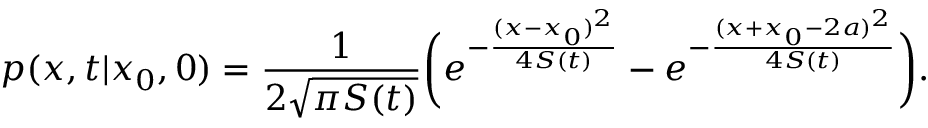<formula> <loc_0><loc_0><loc_500><loc_500>p ( x , t | x _ { 0 } , 0 ) = \frac { 1 } { 2 \sqrt { \pi S ( t ) } } \left ( e ^ { - \frac { ( x - x _ { 0 } ) ^ { 2 } } { 4 S ( t ) } } - e ^ { - \frac { ( x + x _ { 0 } - 2 a ) ^ { 2 } } { 4 S ( t ) } } \right ) .</formula> 